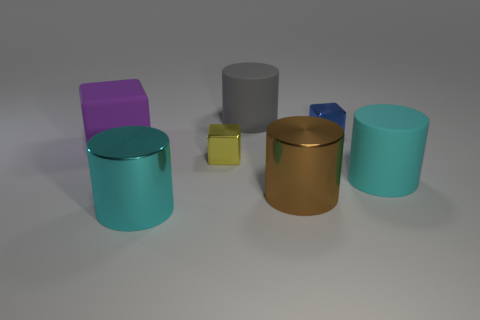Can you describe the lighting of the scene? The lighting of the scene appears to be coming from above, casting soft shadows beneath the objects. It provides a diffused illumination which accentuates the objects' colors and gives the scene a calm, ambient feel. 